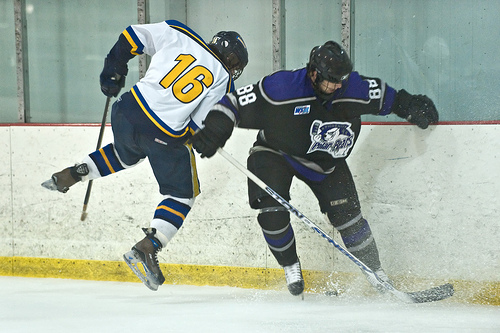<image>
Can you confirm if the helmet is on the man? No. The helmet is not positioned on the man. They may be near each other, but the helmet is not supported by or resting on top of the man. 